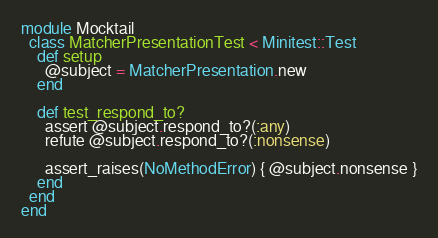Convert code to text. <code><loc_0><loc_0><loc_500><loc_500><_Ruby_>
module Mocktail
  class MatcherPresentationTest < Minitest::Test
    def setup
      @subject = MatcherPresentation.new
    end

    def test_respond_to?
      assert @subject.respond_to?(:any)
      refute @subject.respond_to?(:nonsense)

      assert_raises(NoMethodError) { @subject.nonsense }
    end
  end
end
</code> 